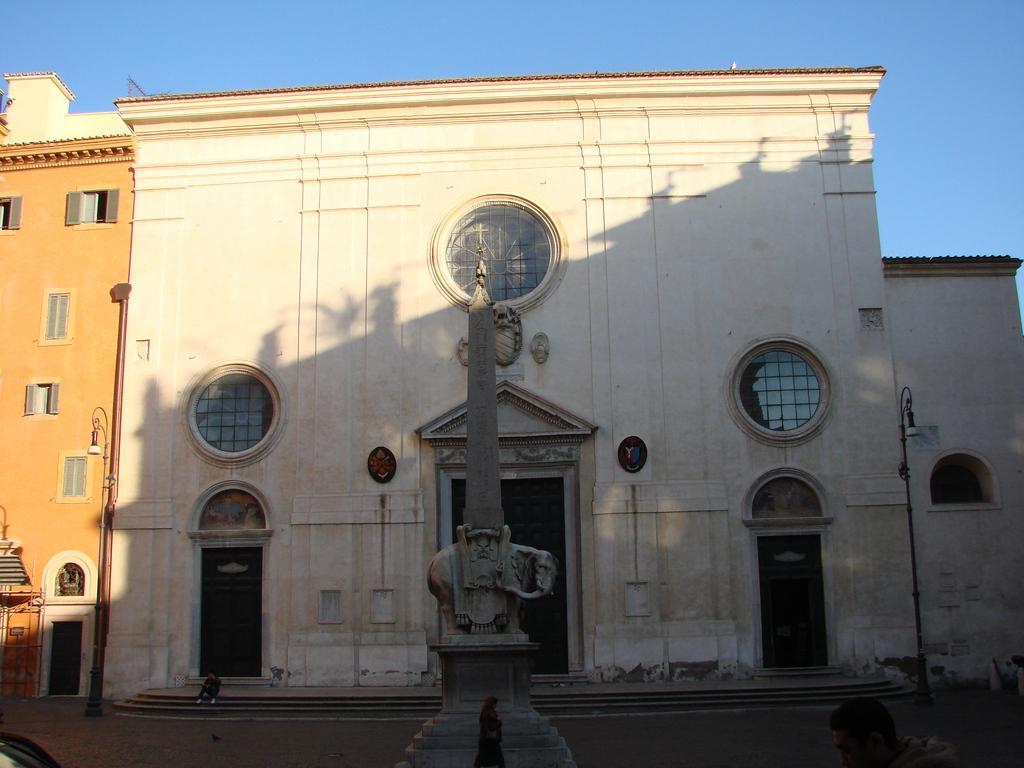Can you describe this image briefly? In this image I can see a sculpture like thing in the front. In the background I can see two poles, two street lights, few buildings and the sky. On the bottom right side of the image I can see a person and I can also see an object on the bottom left corner of the image. In the background I can also see one person is sitting. 